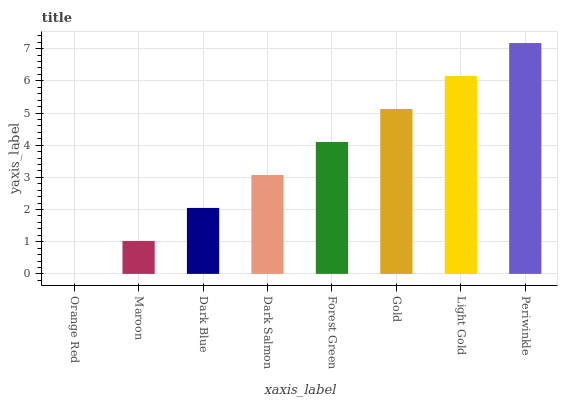Is Orange Red the minimum?
Answer yes or no. Yes. Is Periwinkle the maximum?
Answer yes or no. Yes. Is Maroon the minimum?
Answer yes or no. No. Is Maroon the maximum?
Answer yes or no. No. Is Maroon greater than Orange Red?
Answer yes or no. Yes. Is Orange Red less than Maroon?
Answer yes or no. Yes. Is Orange Red greater than Maroon?
Answer yes or no. No. Is Maroon less than Orange Red?
Answer yes or no. No. Is Forest Green the high median?
Answer yes or no. Yes. Is Dark Salmon the low median?
Answer yes or no. Yes. Is Orange Red the high median?
Answer yes or no. No. Is Periwinkle the low median?
Answer yes or no. No. 